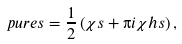Convert formula to latex. <formula><loc_0><loc_0><loc_500><loc_500>\ p u r e s = \frac { 1 } { 2 } \left ( \chi s + \i i \chi h s \right ) ,</formula> 